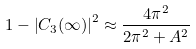Convert formula to latex. <formula><loc_0><loc_0><loc_500><loc_500>1 - \left | C _ { 3 } ( \infty ) \right | ^ { 2 } \approx \frac { 4 \pi ^ { 2 } } { 2 \pi ^ { 2 } + A ^ { 2 } }</formula> 